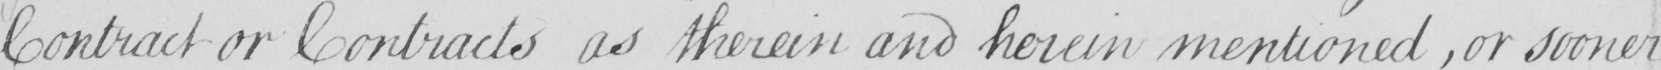Can you tell me what this handwritten text says? contract or Contracts as therein and herein mentioned , or sooner 